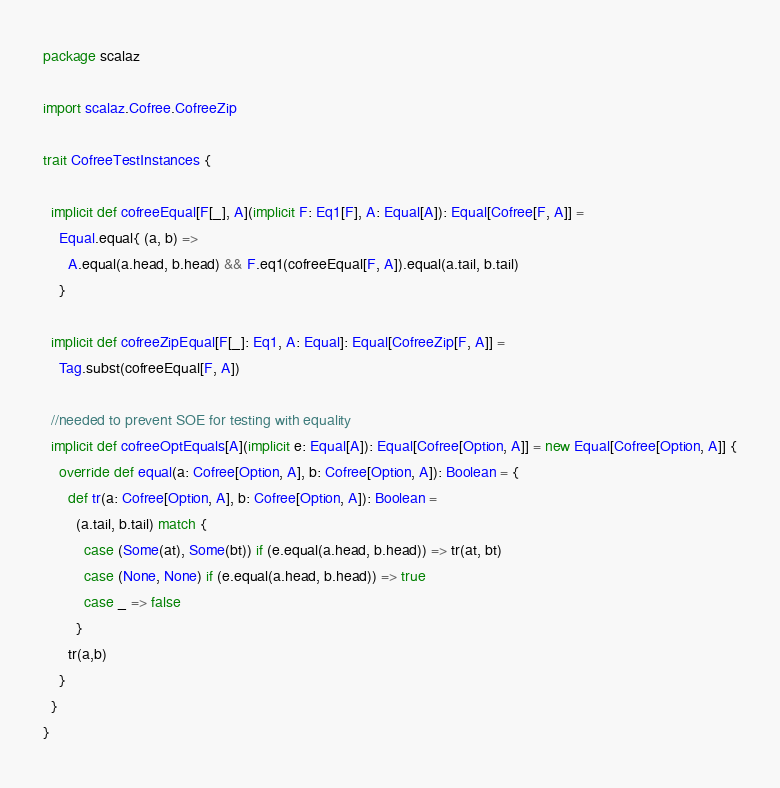<code> <loc_0><loc_0><loc_500><loc_500><_Scala_>package scalaz

import scalaz.Cofree.CofreeZip

trait CofreeTestInstances {

  implicit def cofreeEqual[F[_], A](implicit F: Eq1[F], A: Equal[A]): Equal[Cofree[F, A]] =
    Equal.equal{ (a, b) =>
      A.equal(a.head, b.head) && F.eq1(cofreeEqual[F, A]).equal(a.tail, b.tail)
    }

  implicit def cofreeZipEqual[F[_]: Eq1, A: Equal]: Equal[CofreeZip[F, A]] =
    Tag.subst(cofreeEqual[F, A])

  //needed to prevent SOE for testing with equality
  implicit def cofreeOptEquals[A](implicit e: Equal[A]): Equal[Cofree[Option, A]] = new Equal[Cofree[Option, A]] {
    override def equal(a: Cofree[Option, A], b: Cofree[Option, A]): Boolean = {
      def tr(a: Cofree[Option, A], b: Cofree[Option, A]): Boolean =
        (a.tail, b.tail) match {
          case (Some(at), Some(bt)) if (e.equal(a.head, b.head)) => tr(at, bt)
          case (None, None) if (e.equal(a.head, b.head)) => true
          case _ => false
        }
      tr(a,b)
    }
  }
}
</code> 